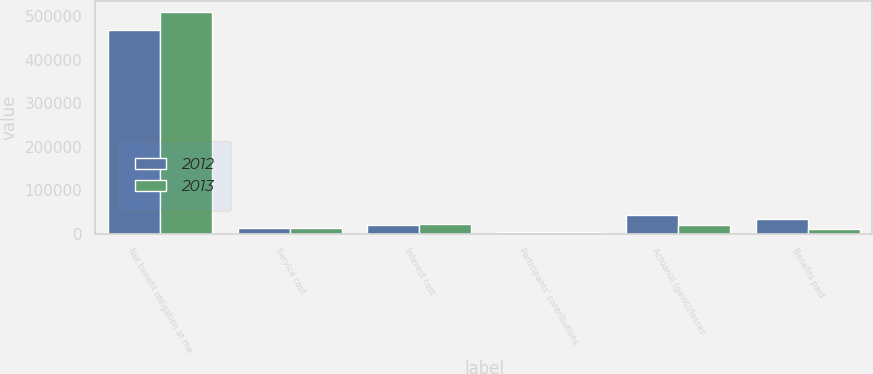<chart> <loc_0><loc_0><loc_500><loc_500><stacked_bar_chart><ecel><fcel>Net benefit obligation at the<fcel>Service cost<fcel>Interest cost<fcel>Participants' contributions<fcel>Actuarial (gains)/losses<fcel>Benefits paid<nl><fcel>2012<fcel>468439<fcel>13814<fcel>18569<fcel>3071<fcel>42689<fcel>33960<nl><fcel>2013<fcel>509605<fcel>12838<fcel>20923<fcel>3200<fcel>20342<fcel>10978<nl></chart> 